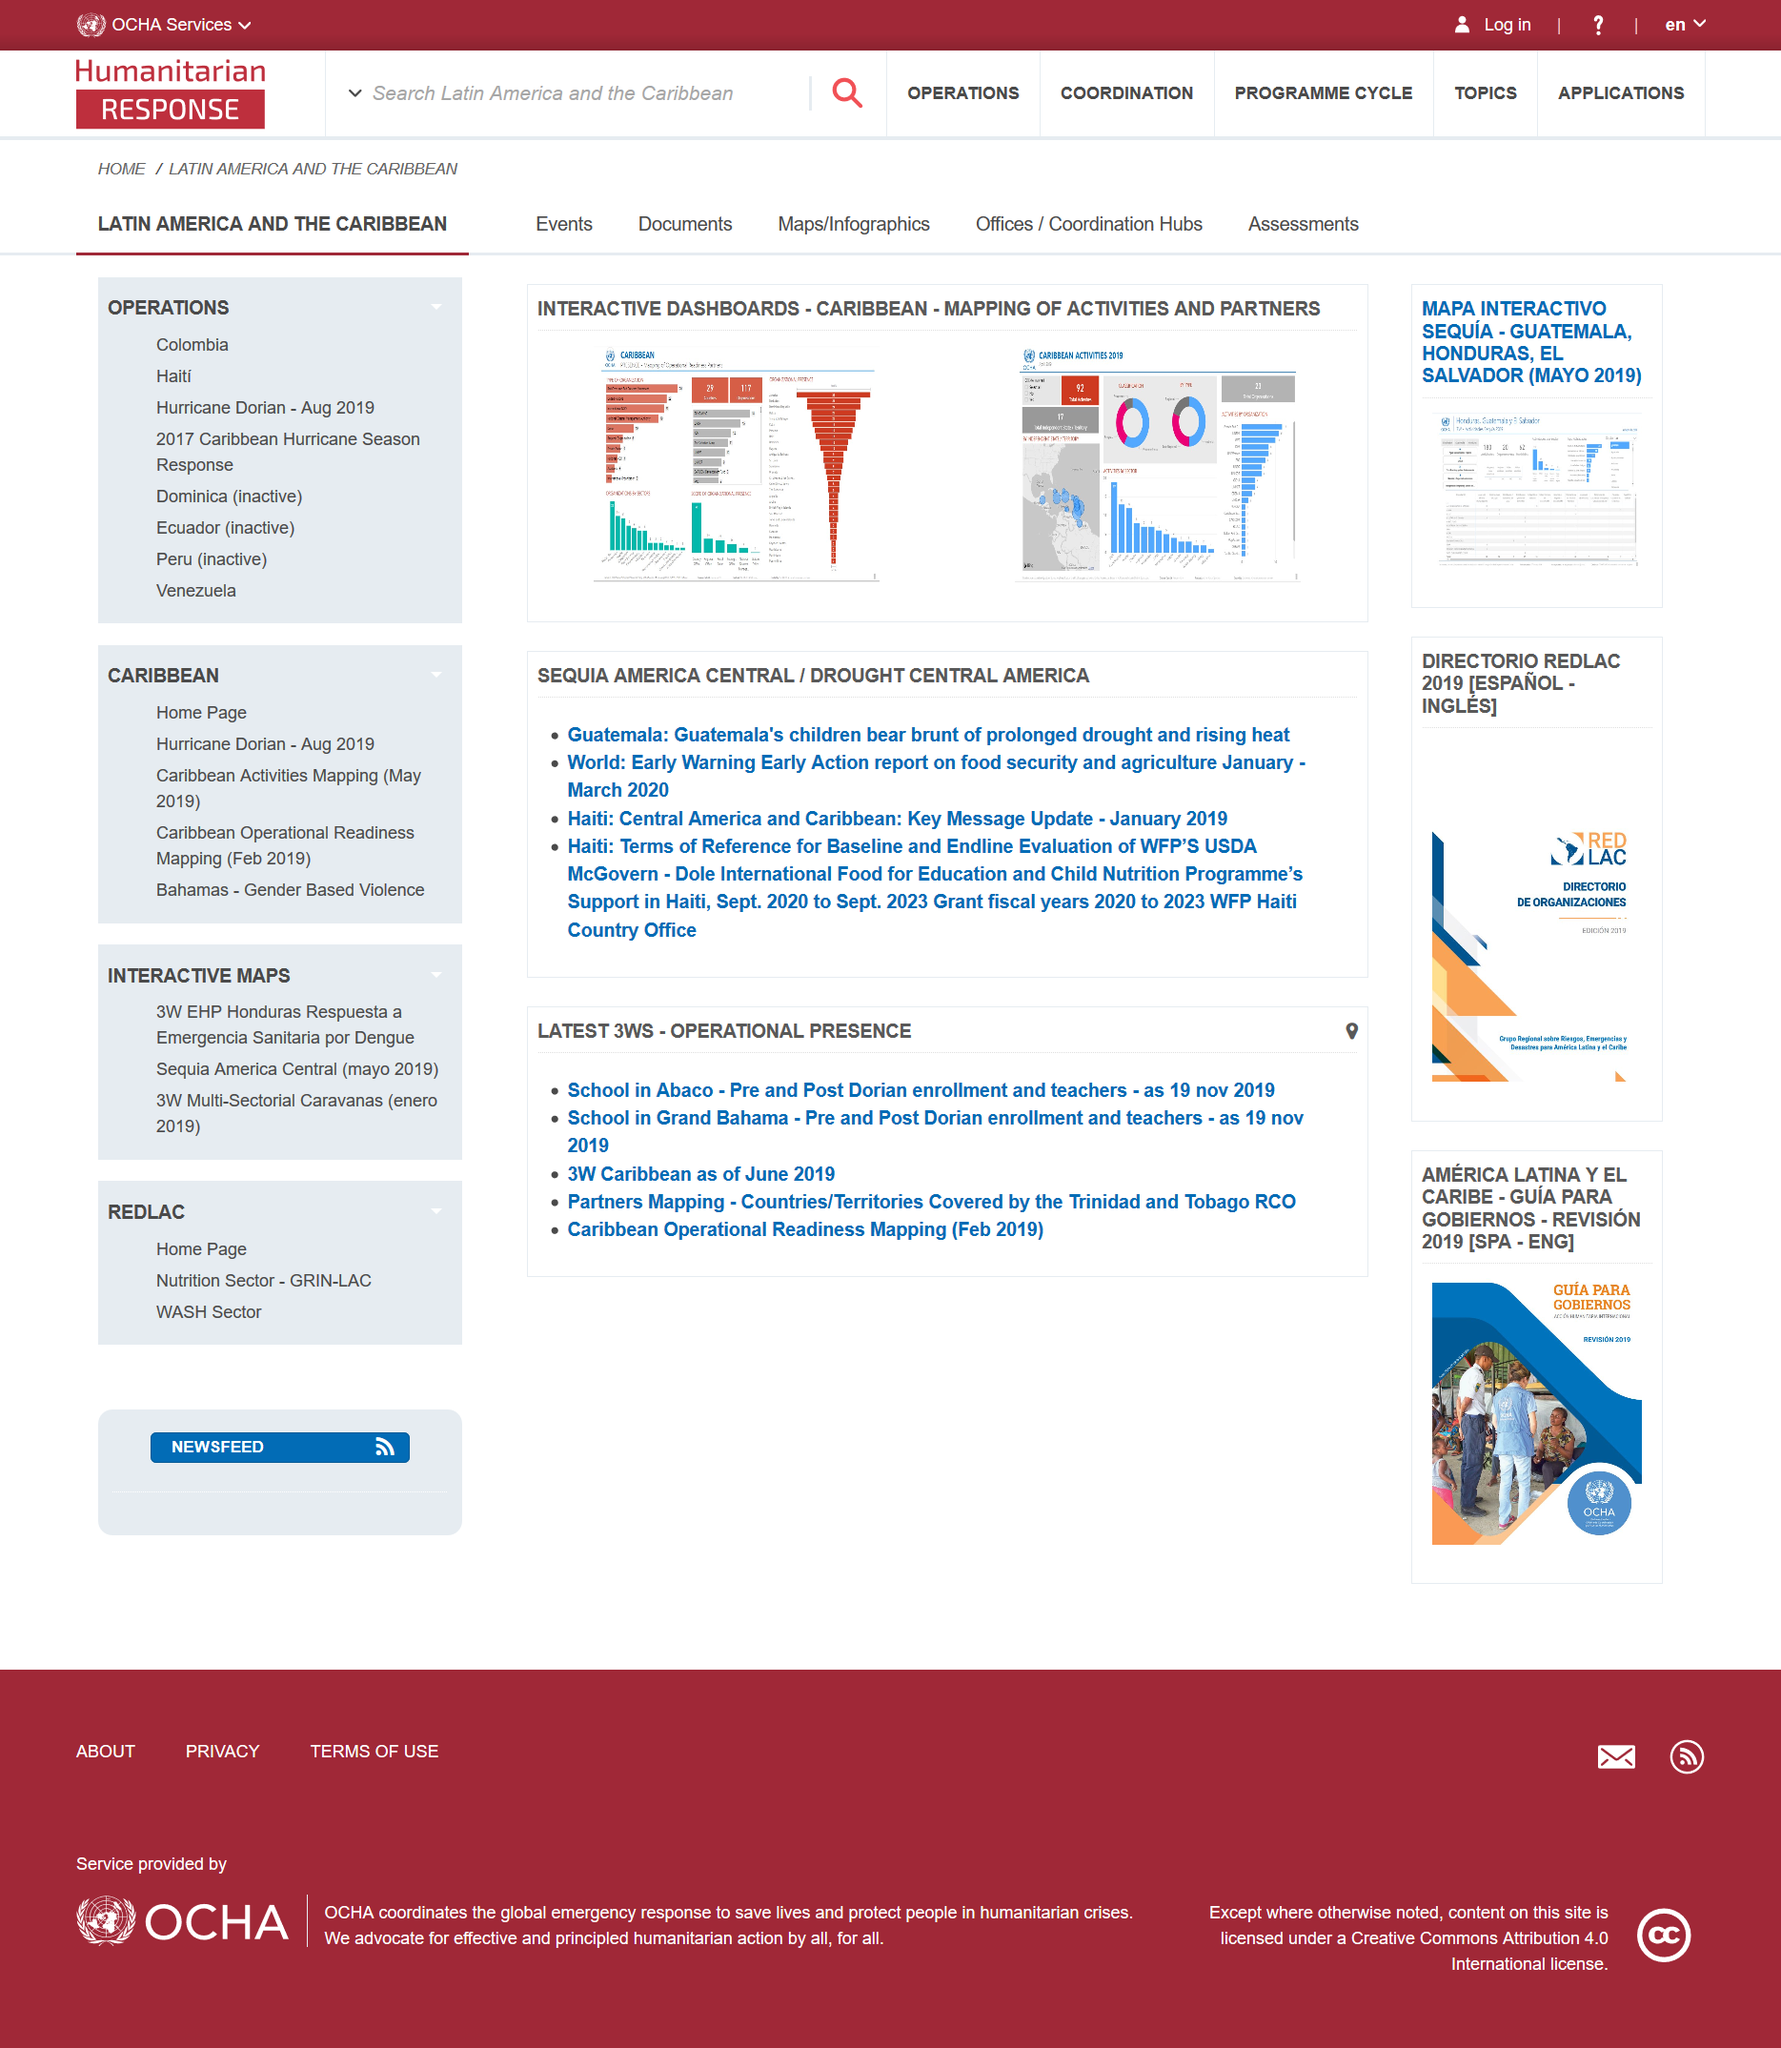Identify some key points in this picture. On January 2019, the Key Message Update for Haiti in Central America and Caribbean was released. The Interactive Dashboard document mentions two countries: Guatemala and Haiti. The report titled 'World: Early Warning Early Action' was based on data from January and March 2020. 